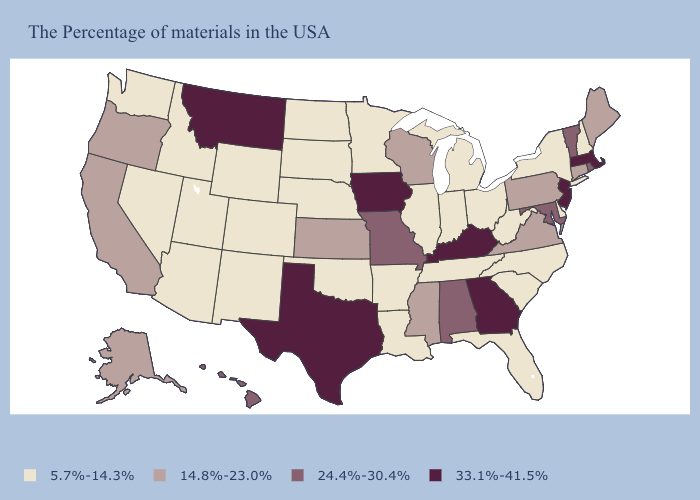Name the states that have a value in the range 24.4%-30.4%?
Short answer required. Rhode Island, Vermont, Maryland, Alabama, Missouri, Hawaii. Does Utah have the highest value in the West?
Answer briefly. No. How many symbols are there in the legend?
Write a very short answer. 4. Name the states that have a value in the range 24.4%-30.4%?
Keep it brief. Rhode Island, Vermont, Maryland, Alabama, Missouri, Hawaii. Which states have the lowest value in the MidWest?
Quick response, please. Ohio, Michigan, Indiana, Illinois, Minnesota, Nebraska, South Dakota, North Dakota. Does Illinois have the highest value in the MidWest?
Quick response, please. No. How many symbols are there in the legend?
Concise answer only. 4. What is the lowest value in the MidWest?
Be succinct. 5.7%-14.3%. What is the value of West Virginia?
Keep it brief. 5.7%-14.3%. Name the states that have a value in the range 24.4%-30.4%?
Be succinct. Rhode Island, Vermont, Maryland, Alabama, Missouri, Hawaii. What is the value of Maryland?
Keep it brief. 24.4%-30.4%. Does the map have missing data?
Short answer required. No. Among the states that border South Carolina , which have the lowest value?
Concise answer only. North Carolina. Which states have the lowest value in the USA?
Quick response, please. New Hampshire, New York, Delaware, North Carolina, South Carolina, West Virginia, Ohio, Florida, Michigan, Indiana, Tennessee, Illinois, Louisiana, Arkansas, Minnesota, Nebraska, Oklahoma, South Dakota, North Dakota, Wyoming, Colorado, New Mexico, Utah, Arizona, Idaho, Nevada, Washington. Does Missouri have the highest value in the MidWest?
Answer briefly. No. 